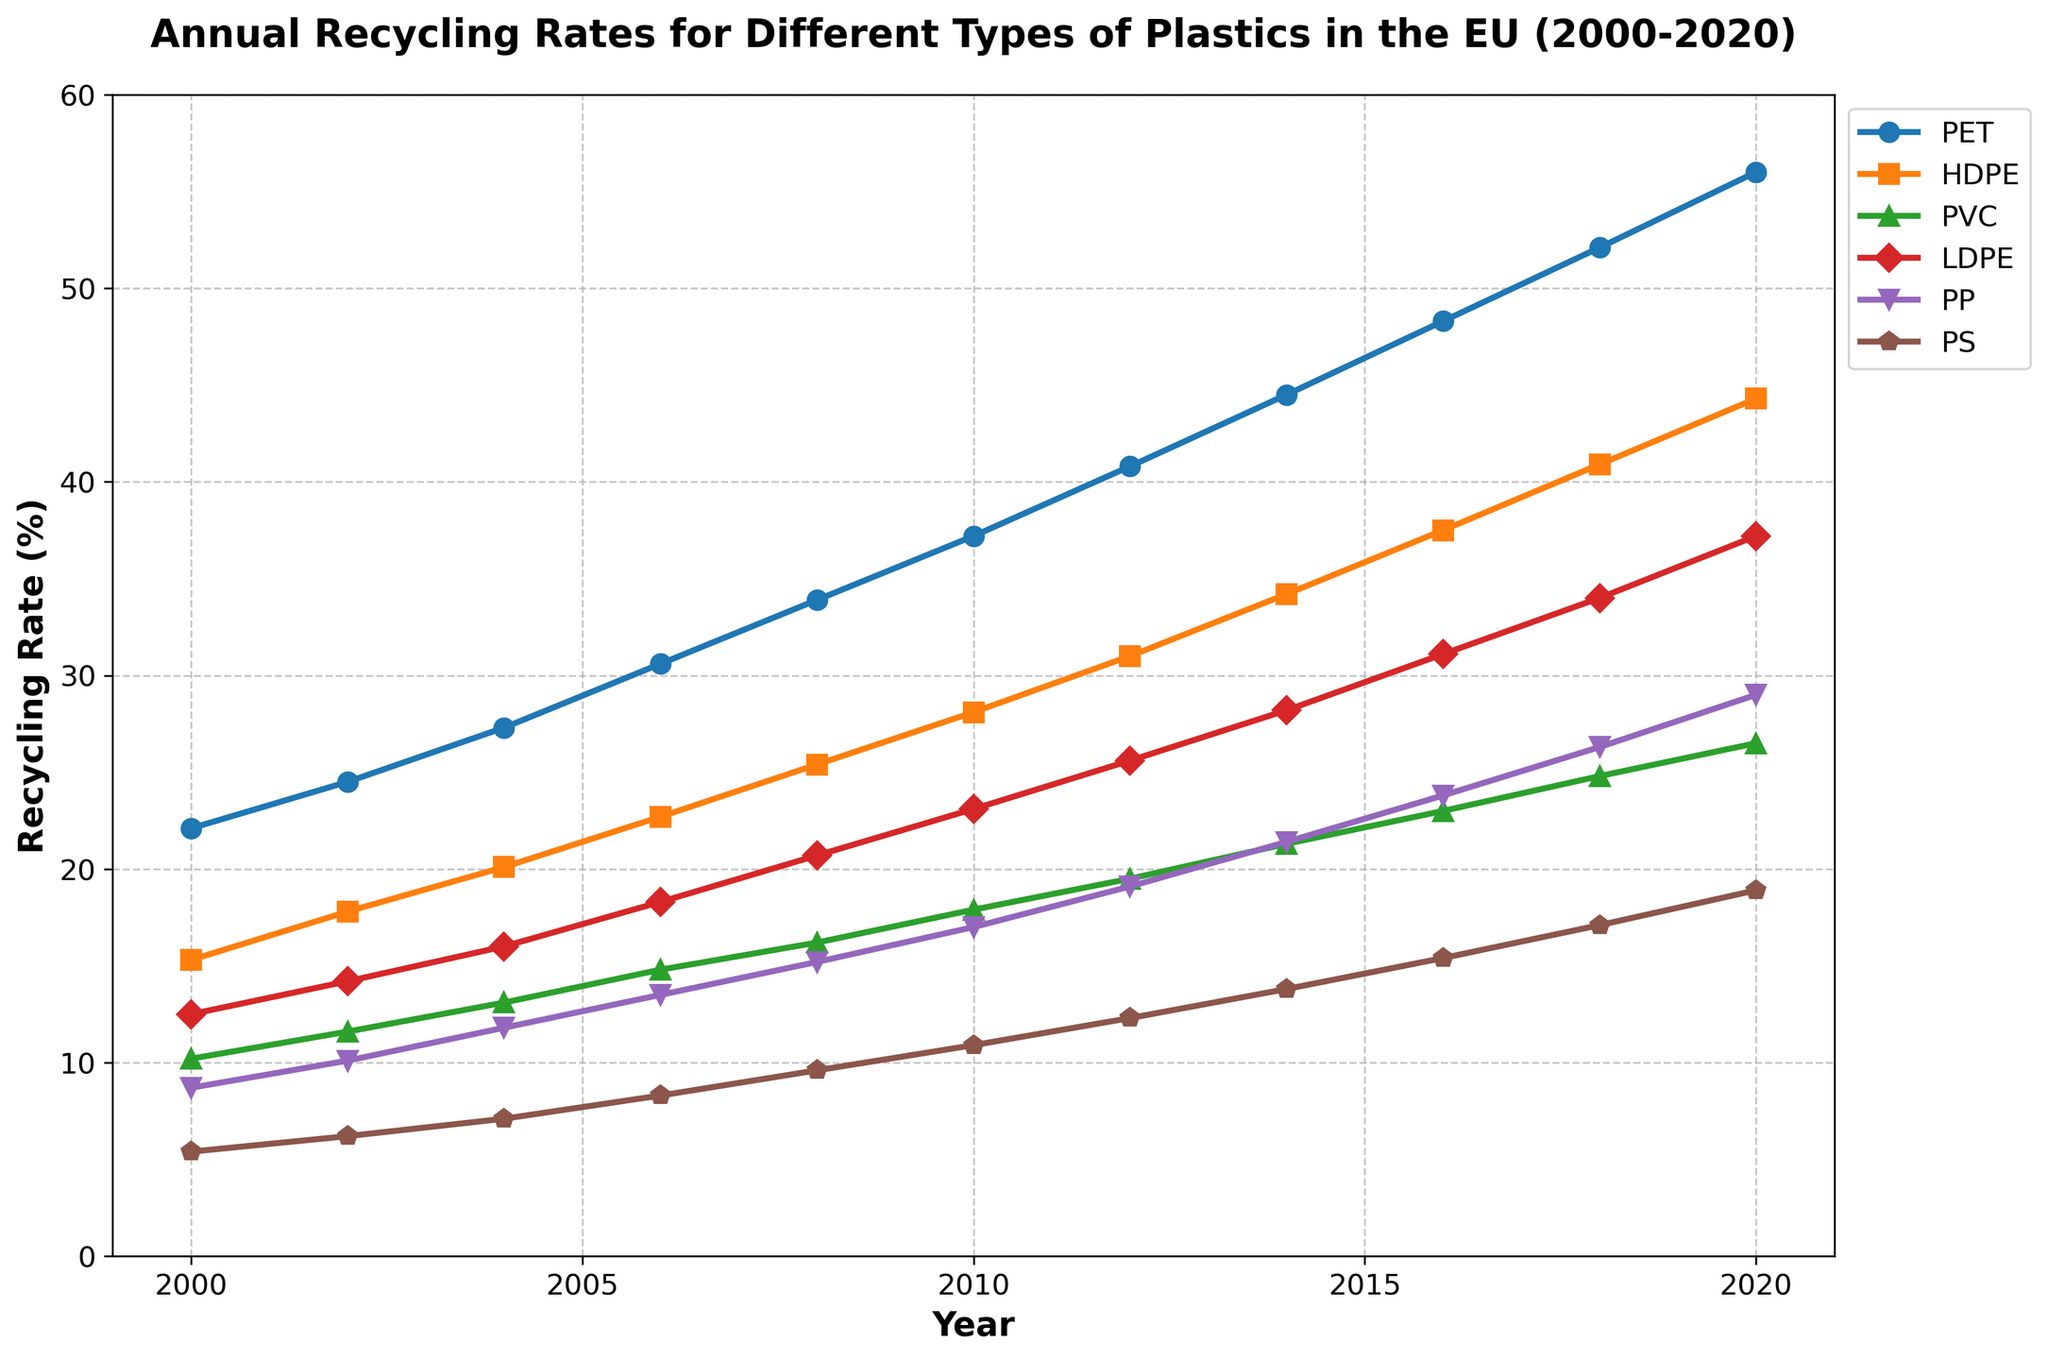What was the recycling rate for PET in 2010? Locate the PET line (marked with circles) and find the intersection with the year 2010. The value is 37.2%.
Answer: 37.2% Which type of plastic had the highest recycling rate in 2020? Compare the recycling rates of all six types of plastics in 2020. PET had the highest recycling rate.
Answer: PET What are the recycling rates for HDPE and PP in 2016, and what is their difference? Locate the HDPE and PP lines and find their intersection with the year 2016. The values are 37.5% for HDPE and 23.8% for PP. Their difference is 37.5% - 23.8% = 13.7%.
Answer: 13.7% Between which years did LDPE see the highest increase in recycling rate? Measure the differences in recycling rates for LDPE between each two-year interval. The highest increase is between 2018 (34.0%) and 2020 (37.2%), an increment of 3.2%.
Answer: Between 2018 and 2020 By how much did the recycling rate of PS increase from 2000 to 2020? Locate the PS line and compare the recycling rates for the years 2000 and 2020. The values are 5.4% in 2000 and 18.9% in 2020. The increase is 18.9% - 5.4% = 13.5%.
Answer: 13.5% Which type of plastic had the lowest recycling rate in 2008, and what was the rate? Compare the recycling rates of all six types of plastics in 2008. PS had the lowest recycling rate, which was 9.6%.
Answer: PS, 9.6% In which year did PVC's recycling rate first exceed 20%? Follow the PVC line and determine the first year it crosses the 20% mark. It is in 2014.
Answer: 2014 Which type of plastic shows the most substantial growth trend from 2000 to 2020? Evaluate the overall trend lines for all six types of plastics from 2000 to 2020. PET shows the most substantial growth.
Answer: PET How many types of plastics had a recycling rate under 20% in 2006? Identify which plastics had recycling rates below 20% in 2006 by checking their intersection points. HDPE, PVC, LDPE, PP, and PS all had rates under 20%.
Answer: 5 What was the median recycling rate for the year 2004? List the recycling rates for all six types of plastics in 2004 (27.3%, 20.1%, 13.1%, 16.0%, 11.8%, 7.1%), then find the middle value(s). The two middle values are 16.0% and 13.1%, so the median is (16.0 + 13.1) / 2 = 14.55%.
Answer: 14.55% 